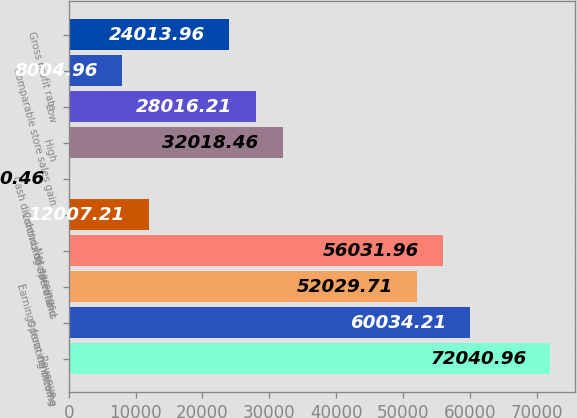Convert chart. <chart><loc_0><loc_0><loc_500><loc_500><bar_chart><fcel>Revenue<fcel>Operating income<fcel>Earnings from continuing<fcel>Net earnings<fcel>Continuing operations<fcel>Cash dividends declared and<fcel>High<fcel>Low<fcel>Comparable store sales gain<fcel>Gross profit rate<nl><fcel>72041<fcel>60034.2<fcel>52029.7<fcel>56032<fcel>12007.2<fcel>0.46<fcel>32018.5<fcel>28016.2<fcel>8004.96<fcel>24014<nl></chart> 